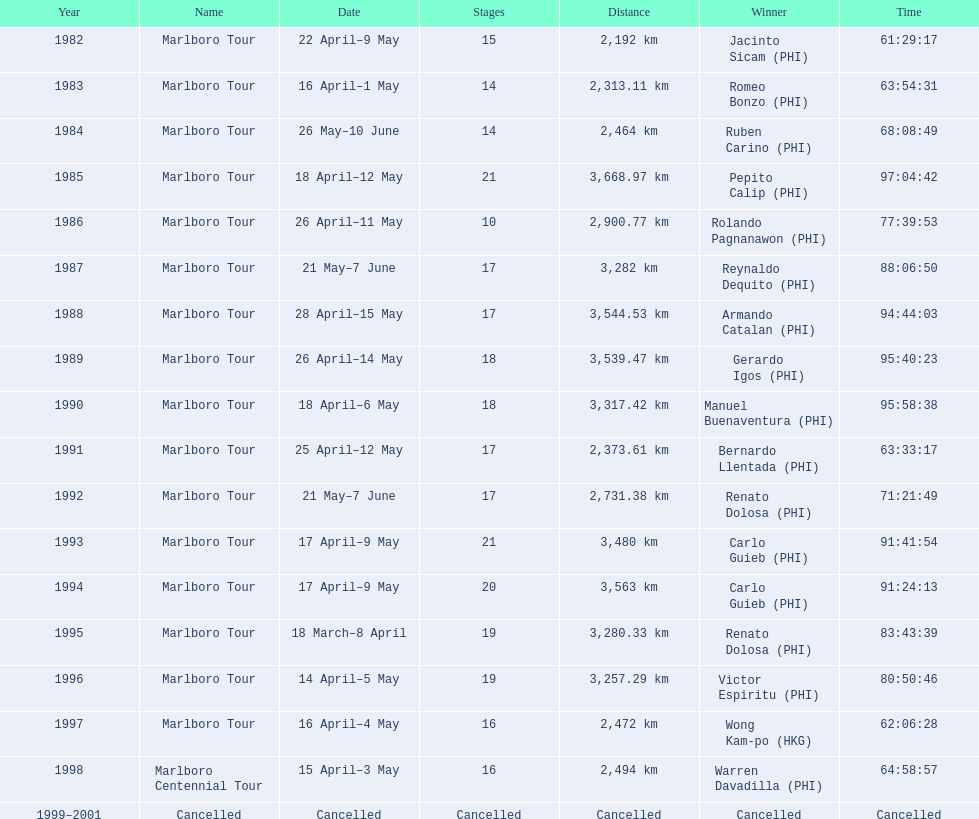What was the yearly distance covered by the marlboro tour? 2,192 km, 2,313.11 km, 2,464 km, 3,668.97 km, 2,900.77 km, 3,282 km, 3,544.53 km, 3,539.47 km, 3,317.42 km, 2,373.61 km, 2,731.38 km, 3,480 km, 3,563 km, 3,280.33 km, 3,257.29 km, 2,472 km, 2,494 km, Cancelled. In which year was the maximum distance traveled? 1985. How much distance was covered in that particular year? 3,668.97 km. 